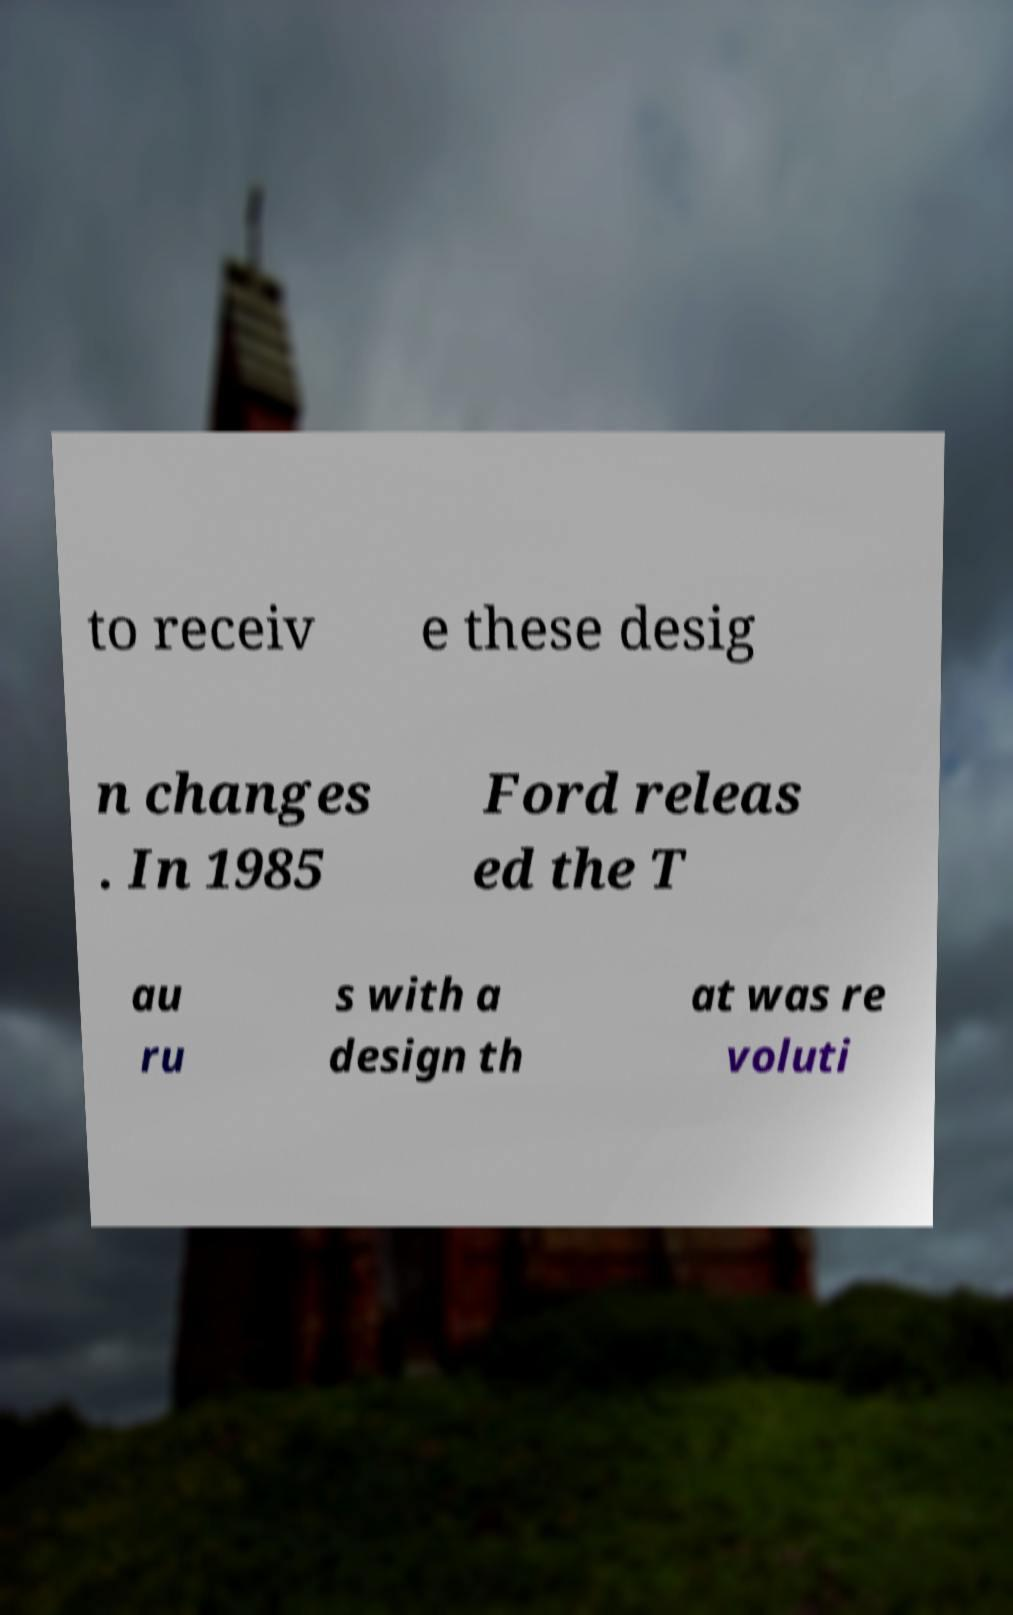What messages or text are displayed in this image? I need them in a readable, typed format. to receiv e these desig n changes . In 1985 Ford releas ed the T au ru s with a design th at was re voluti 